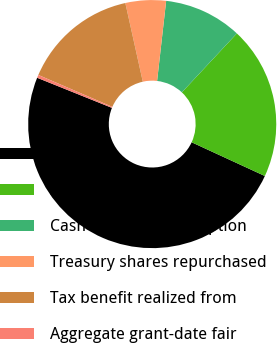Convert chart to OTSL. <chart><loc_0><loc_0><loc_500><loc_500><pie_chart><fcel>Millions<fcel>Intrinsic value of stock<fcel>Cash received from option<fcel>Treasury shares repurchased<fcel>Tax benefit realized from<fcel>Aggregate grant-date fair<nl><fcel>49.22%<fcel>19.92%<fcel>10.16%<fcel>5.27%<fcel>15.04%<fcel>0.39%<nl></chart> 